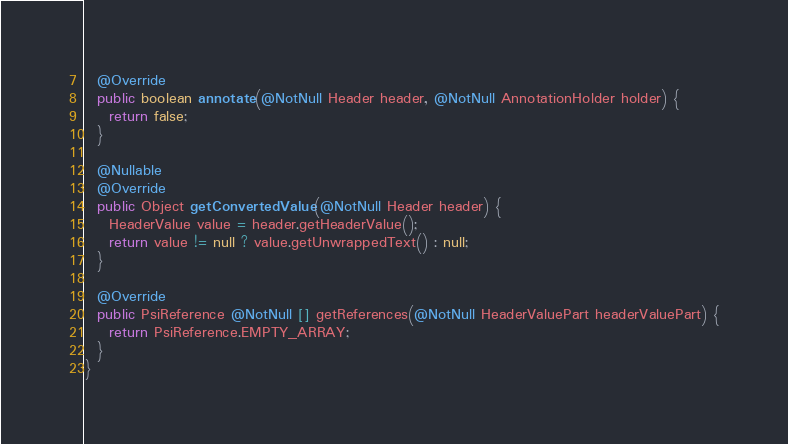<code> <loc_0><loc_0><loc_500><loc_500><_Java_>
  @Override
  public boolean annotate(@NotNull Header header, @NotNull AnnotationHolder holder) {
    return false;
  }

  @Nullable
  @Override
  public Object getConvertedValue(@NotNull Header header) {
    HeaderValue value = header.getHeaderValue();
    return value != null ? value.getUnwrappedText() : null;
  }

  @Override
  public PsiReference @NotNull [] getReferences(@NotNull HeaderValuePart headerValuePart) {
    return PsiReference.EMPTY_ARRAY;
  }
}
</code> 